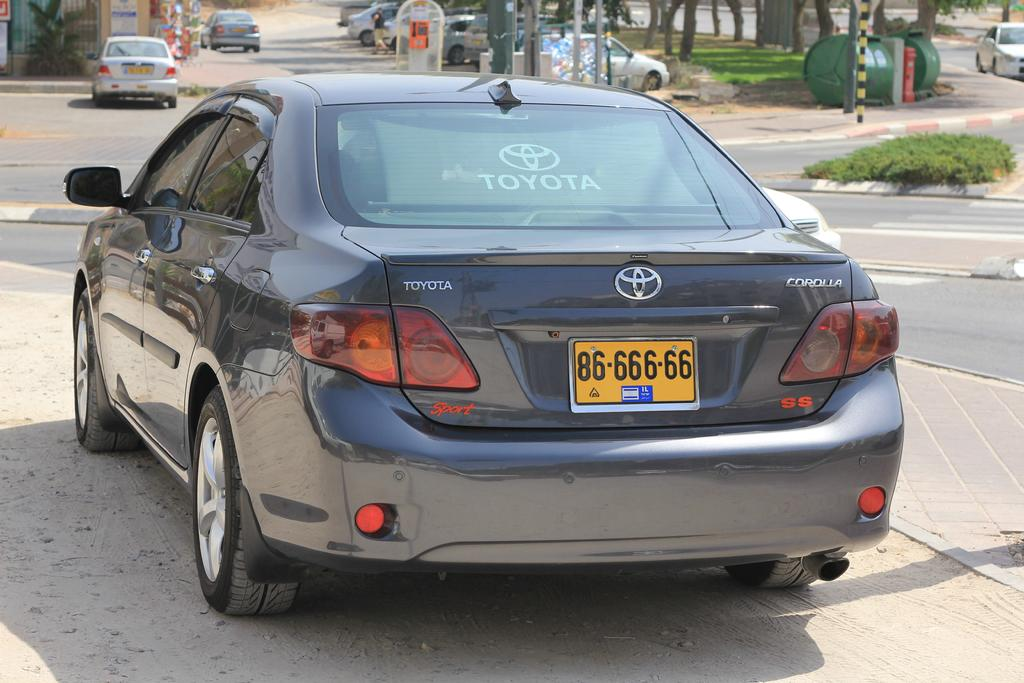<image>
Present a compact description of the photo's key features. Back side picture of a  Toyota Corolla with number plate 86-666-66. 